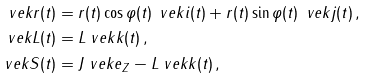<formula> <loc_0><loc_0><loc_500><loc_500>\ v e k { r } ( t ) & = r ( t ) \cos \varphi ( t ) \, \ v e k { i } ( t ) + r ( t ) \sin \varphi ( t ) \, \ v e k { j } ( t ) \, , \\ \ v e k { L } ( t ) & = L \ v e k { k } ( t ) \, , \\ \ v e k { S } ( t ) & = J \ v e k { e } _ { Z } - L \ v e k { k } ( t ) \, ,</formula> 